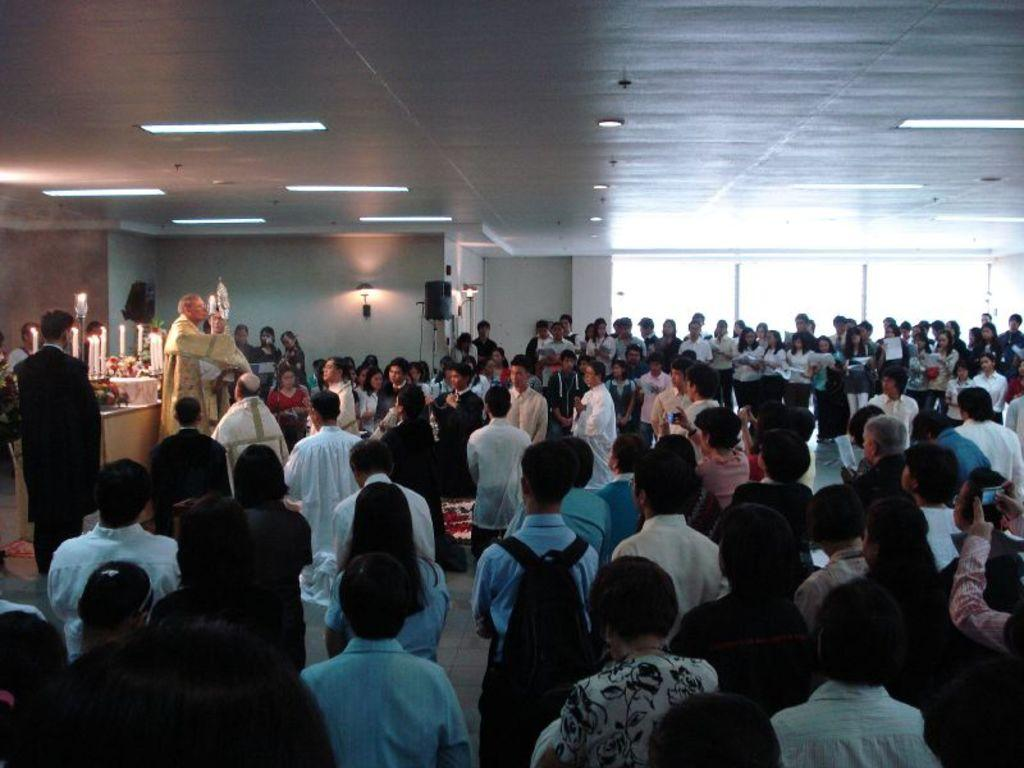What are the people in the image doing? The persons standing on the floor are likely engaged in some activity or event. What can be seen on the left side of the image? There are tables and candles on the left side of the image. What is visible in the background of the image? There are windows and a wall in the background of the image. What type of button can be seen on the wall in the image? There is no button present on the wall in the image. 